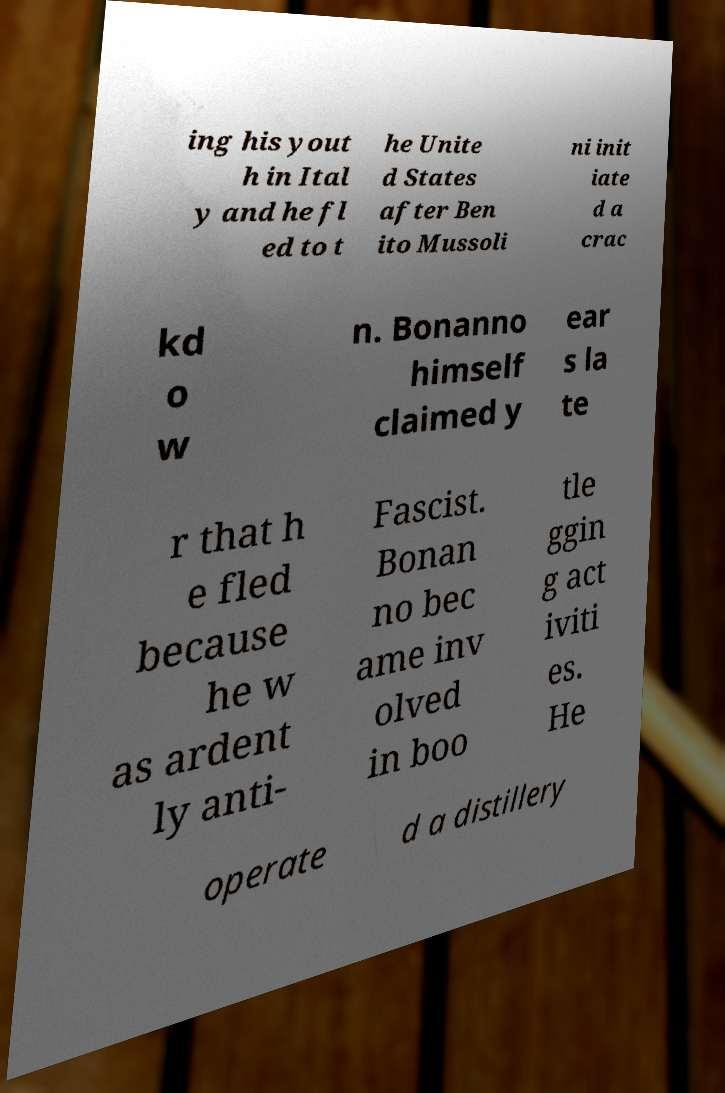I need the written content from this picture converted into text. Can you do that? ing his yout h in Ital y and he fl ed to t he Unite d States after Ben ito Mussoli ni init iate d a crac kd o w n. Bonanno himself claimed y ear s la te r that h e fled because he w as ardent ly anti- Fascist. Bonan no bec ame inv olved in boo tle ggin g act iviti es. He operate d a distillery 